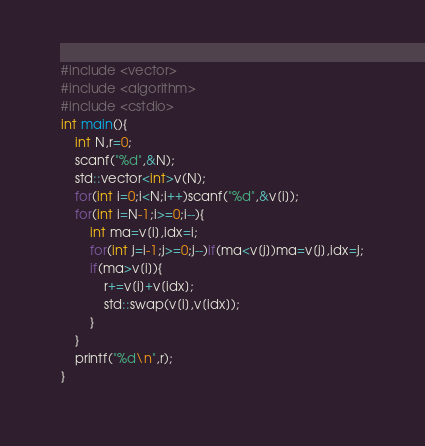Convert code to text. <code><loc_0><loc_0><loc_500><loc_500><_C_>#include <vector>
#include <algorithm>
#include <cstdio>
int main(){
	int N,r=0;
	scanf("%d",&N);
	std::vector<int>v(N);
	for(int i=0;i<N;i++)scanf("%d",&v[i]);
	for(int i=N-1;i>=0;i--){
		int ma=v[i],idx=i;
		for(int j=i-1;j>=0;j--)if(ma<v[j])ma=v[j],idx=j;
		if(ma>v[i]){
			r+=v[i]+v[idx];
			std::swap(v[i],v[idx]);
		}
	}
	printf("%d\n",r);
}</code> 